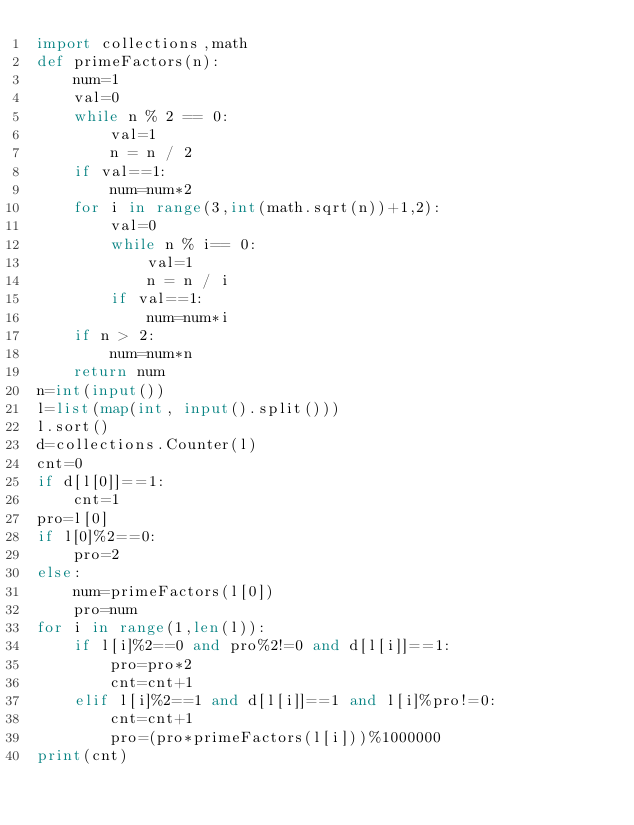<code> <loc_0><loc_0><loc_500><loc_500><_Python_>import collections,math
def primeFactors(n): 
    num=1  
    val=0
    while n % 2 == 0: 
        val=1 
        n = n / 2
    if val==1:
        num=num*2
    for i in range(3,int(math.sqrt(n))+1,2):
        val=0
        while n % i== 0: 
            val=1 
            n = n / i
        if val==1:
            num=num*i
    if n > 2: 
        num=num*n
    return num
n=int(input())
l=list(map(int, input().split()))
l.sort()
d=collections.Counter(l)
cnt=0
if d[l[0]]==1:
    cnt=1
pro=l[0]
if l[0]%2==0:
    pro=2
else:
    num=primeFactors(l[0])
    pro=num
for i in range(1,len(l)):
    if l[i]%2==0 and pro%2!=0 and d[l[i]]==1:
        pro=pro*2
        cnt=cnt+1
    elif l[i]%2==1 and d[l[i]]==1 and l[i]%pro!=0:
        cnt=cnt+1
        pro=(pro*primeFactors(l[i]))%1000000
print(cnt)
</code> 